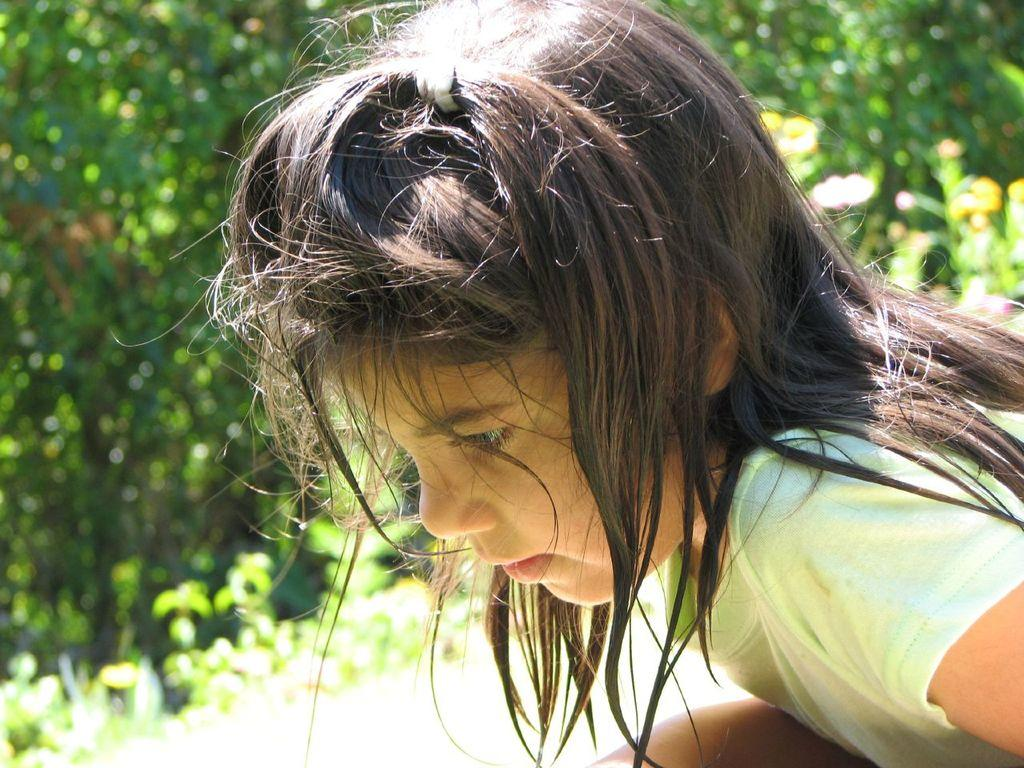Who is the main subject in the image? There is a girl in the image. Can you describe the background of the image? The background of the image is blurry. What can be seen in the background of the image? Leaves are visible in the background of the image. What time does the clock in the image show? There is no clock present in the image. What is the girl doing in the morning in the image? The time of day is not specified in the image, and the girl's actions are not described. What type of material is the wall made of in the image? There is no wall visible in the image. 